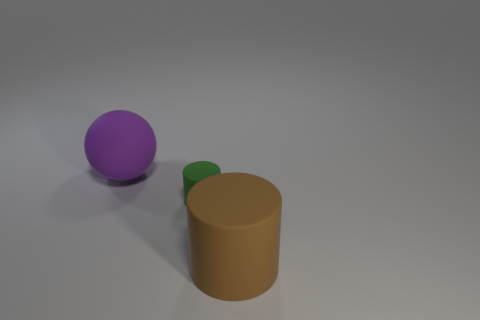How many things are either matte cylinders that are on the left side of the brown matte thing or rubber cylinders to the right of the green matte cylinder?
Make the answer very short. 2. What material is the brown thing that is the same size as the ball?
Provide a succinct answer. Rubber. The big matte ball has what color?
Offer a terse response. Purple. There is a object that is behind the large brown matte thing and in front of the big sphere; what material is it?
Your answer should be compact. Rubber. There is a rubber cylinder behind the big rubber object that is in front of the big purple ball; are there any large matte objects that are behind it?
Ensure brevity in your answer.  Yes. There is a large brown matte thing; are there any brown matte cylinders behind it?
Offer a very short reply. No. What number of other objects are there of the same shape as the large purple thing?
Keep it short and to the point. 0. There is a rubber cylinder that is the same size as the purple rubber sphere; what is its color?
Give a very brief answer. Brown. Are there fewer big purple things that are in front of the purple ball than tiny matte things that are in front of the small green object?
Your answer should be compact. No. There is a big matte ball that is to the left of the large rubber thing in front of the green matte cylinder; how many matte cylinders are behind it?
Give a very brief answer. 0. 